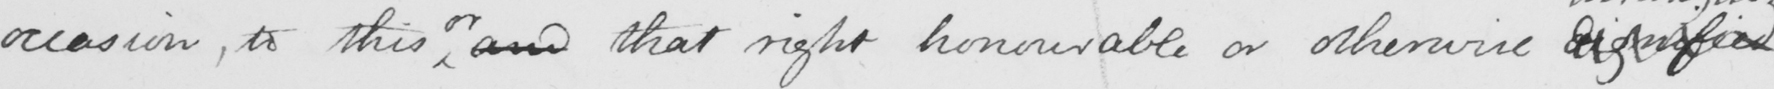Please provide the text content of this handwritten line. occasion , to this orand that right honourable or otherwise dignified 